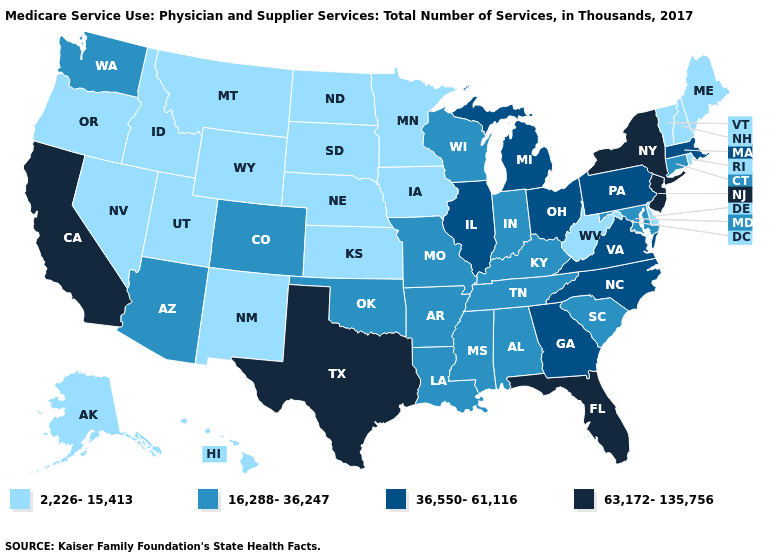What is the value of Wisconsin?
Answer briefly. 16,288-36,247. Name the states that have a value in the range 2,226-15,413?
Write a very short answer. Alaska, Delaware, Hawaii, Idaho, Iowa, Kansas, Maine, Minnesota, Montana, Nebraska, Nevada, New Hampshire, New Mexico, North Dakota, Oregon, Rhode Island, South Dakota, Utah, Vermont, West Virginia, Wyoming. Among the states that border Oregon , which have the lowest value?
Concise answer only. Idaho, Nevada. What is the value of Wyoming?
Short answer required. 2,226-15,413. Does New York have a lower value than Nevada?
Short answer required. No. Does Maryland have a lower value than Massachusetts?
Give a very brief answer. Yes. What is the value of Virginia?
Short answer required. 36,550-61,116. Which states have the lowest value in the USA?
Answer briefly. Alaska, Delaware, Hawaii, Idaho, Iowa, Kansas, Maine, Minnesota, Montana, Nebraska, Nevada, New Hampshire, New Mexico, North Dakota, Oregon, Rhode Island, South Dakota, Utah, Vermont, West Virginia, Wyoming. Among the states that border Virginia , does West Virginia have the highest value?
Keep it brief. No. What is the lowest value in states that border New Hampshire?
Give a very brief answer. 2,226-15,413. Does South Carolina have the same value as South Dakota?
Quick response, please. No. What is the value of Kentucky?
Answer briefly. 16,288-36,247. Name the states that have a value in the range 16,288-36,247?
Write a very short answer. Alabama, Arizona, Arkansas, Colorado, Connecticut, Indiana, Kentucky, Louisiana, Maryland, Mississippi, Missouri, Oklahoma, South Carolina, Tennessee, Washington, Wisconsin. What is the lowest value in the USA?
Keep it brief. 2,226-15,413. What is the value of Tennessee?
Keep it brief. 16,288-36,247. 